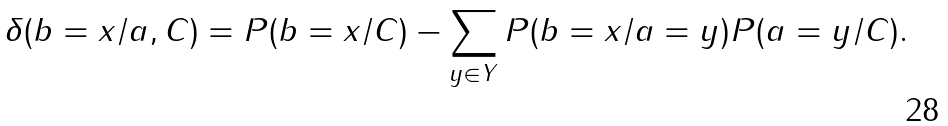Convert formula to latex. <formula><loc_0><loc_0><loc_500><loc_500>\delta ( b = x / a , C ) = { P } ( b = x / C ) - \sum _ { y \in Y } { P } ( b = x / a = y ) { P } ( a = y / C ) .</formula> 